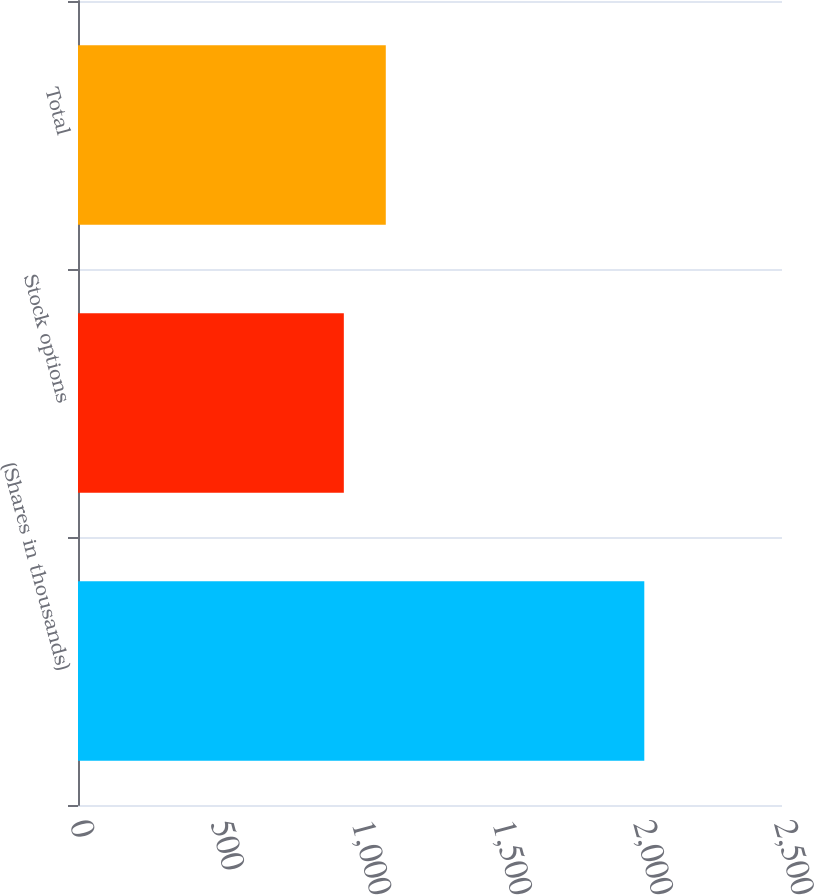<chart> <loc_0><loc_0><loc_500><loc_500><bar_chart><fcel>(Shares in thousands)<fcel>Stock options<fcel>Total<nl><fcel>2011<fcel>944<fcel>1093<nl></chart> 